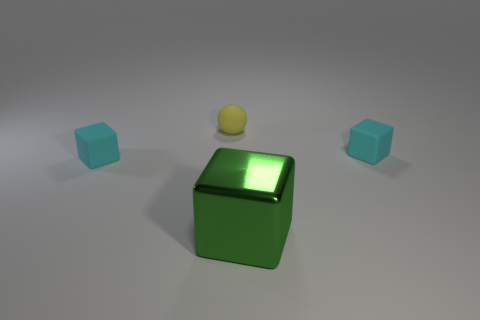Is the number of spheres on the right side of the yellow object less than the number of small spheres?
Your answer should be compact. Yes. What number of green rubber cylinders are there?
Provide a succinct answer. 0. Does the yellow thing have the same shape as the large metallic thing?
Ensure brevity in your answer.  No. How big is the cube that is in front of the tiny cube to the left of the rubber ball?
Keep it short and to the point. Large. Are there any brown rubber cylinders of the same size as the yellow rubber object?
Keep it short and to the point. No. There is a cyan matte cube to the left of the large metal block; does it have the same size as the green metallic object that is to the right of the small yellow thing?
Your answer should be compact. No. What is the shape of the rubber thing behind the small matte object that is to the right of the large metallic thing?
Provide a short and direct response. Sphere. How many tiny things are on the right side of the tiny yellow ball?
Provide a succinct answer. 1. Do the yellow object and the object on the right side of the large green metallic object have the same size?
Provide a short and direct response. Yes. What is the size of the matte thing that is to the right of the yellow rubber object to the left of the small cyan matte cube that is on the right side of the yellow object?
Give a very brief answer. Small. 